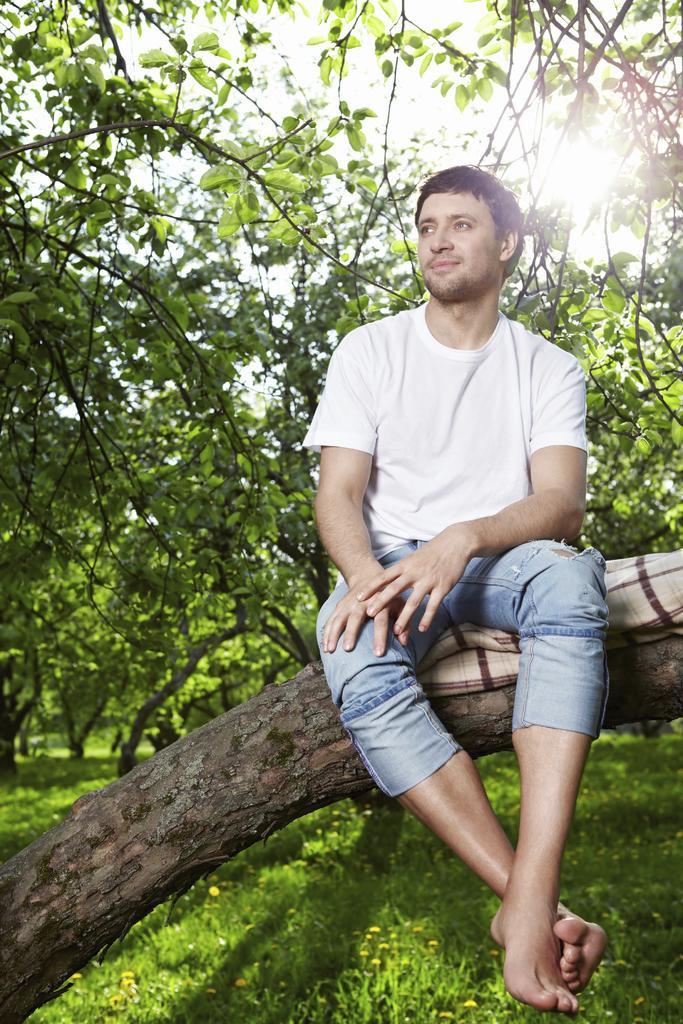Can you describe this image briefly? In this image we can see person sitting on the tree trunk and there is a cloth under the person, in the background there are few trees, and plants at the bottom. 